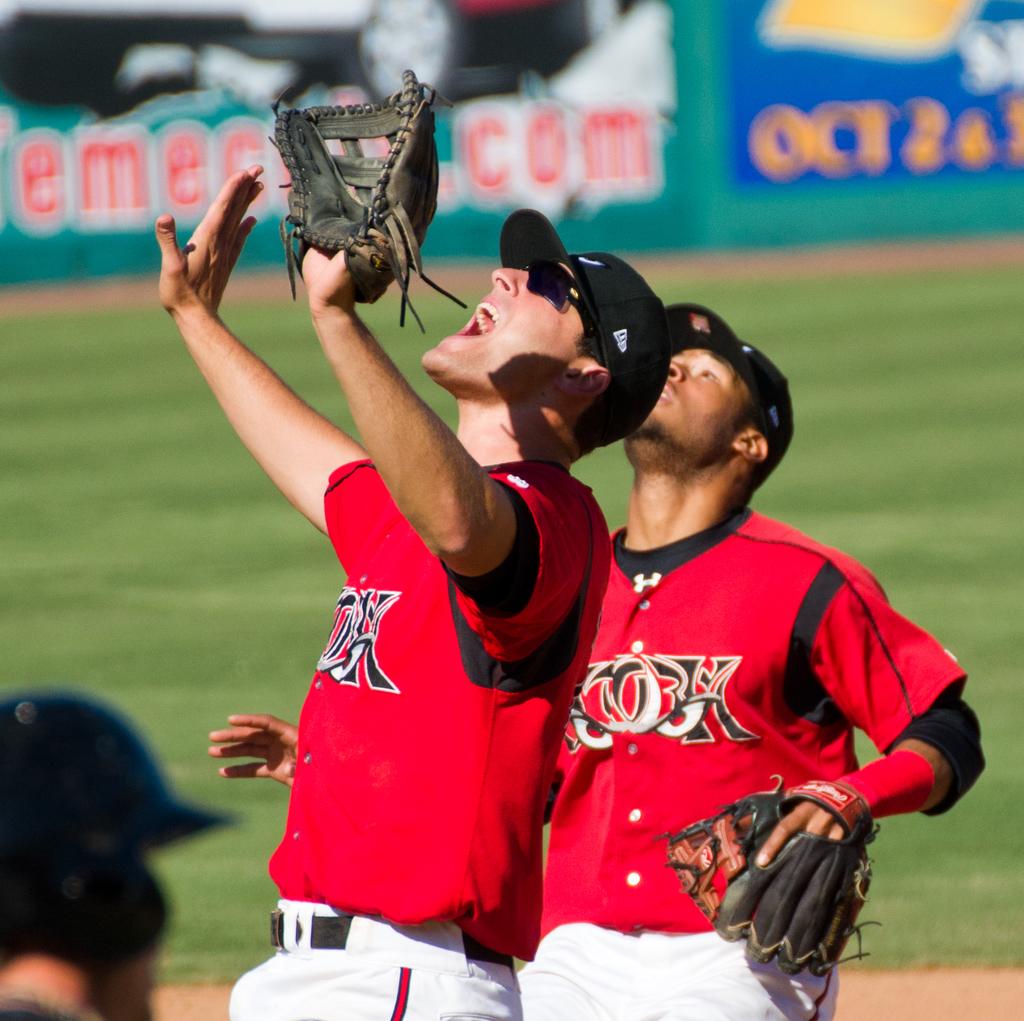What month is mentioned on the banner in the background?
Give a very brief answer. October. 